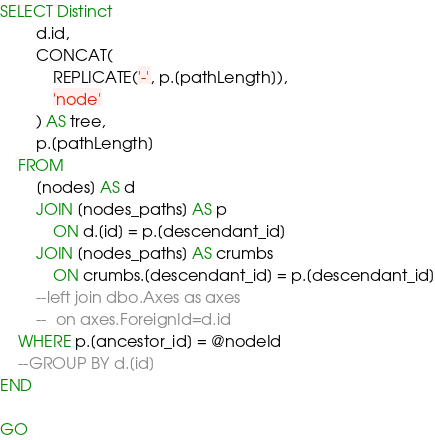Convert code to text. <code><loc_0><loc_0><loc_500><loc_500><_SQL_>

SELECT Distinct 
        d.id,
        CONCAT(
            REPLICATE('-', p.[pathLength]),
            'node'
        ) AS tree,
        p.[pathLength]
    FROM
        [nodes] AS d
        JOIN [nodes_paths] AS p
            ON d.[id] = p.[descendant_id]
        JOIN [nodes_paths] AS crumbs
            ON crumbs.[descendant_id] = p.[descendant_id]
		--left join dbo.Axes as axes
		--	on axes.ForeignId=d.id
    WHERE p.[ancestor_id] = @nodeId
    --GROUP BY d.[id]
END

GO

</code> 